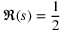<formula> <loc_0><loc_0><loc_500><loc_500>\Re ( s ) = { \frac { 1 } { 2 } }</formula> 